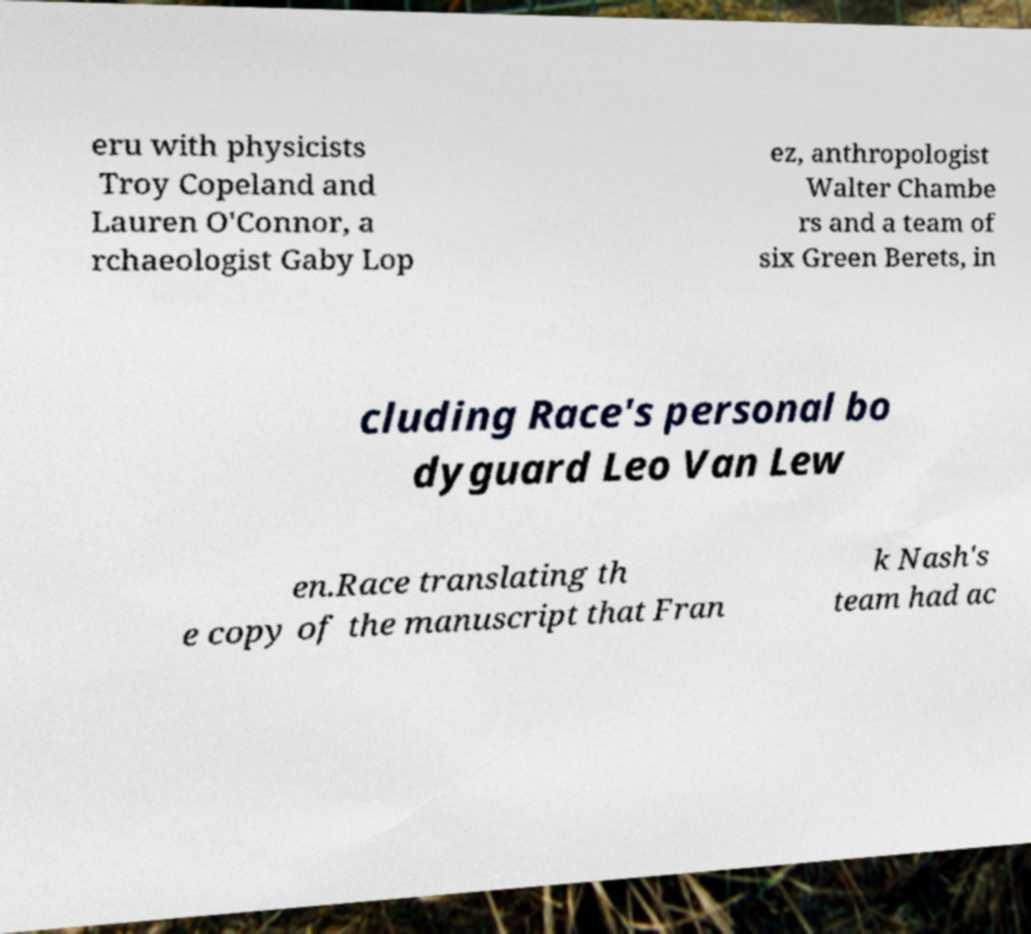Could you extract and type out the text from this image? eru with physicists Troy Copeland and Lauren O'Connor, a rchaeologist Gaby Lop ez, anthropologist Walter Chambe rs and a team of six Green Berets, in cluding Race's personal bo dyguard Leo Van Lew en.Race translating th e copy of the manuscript that Fran k Nash's team had ac 